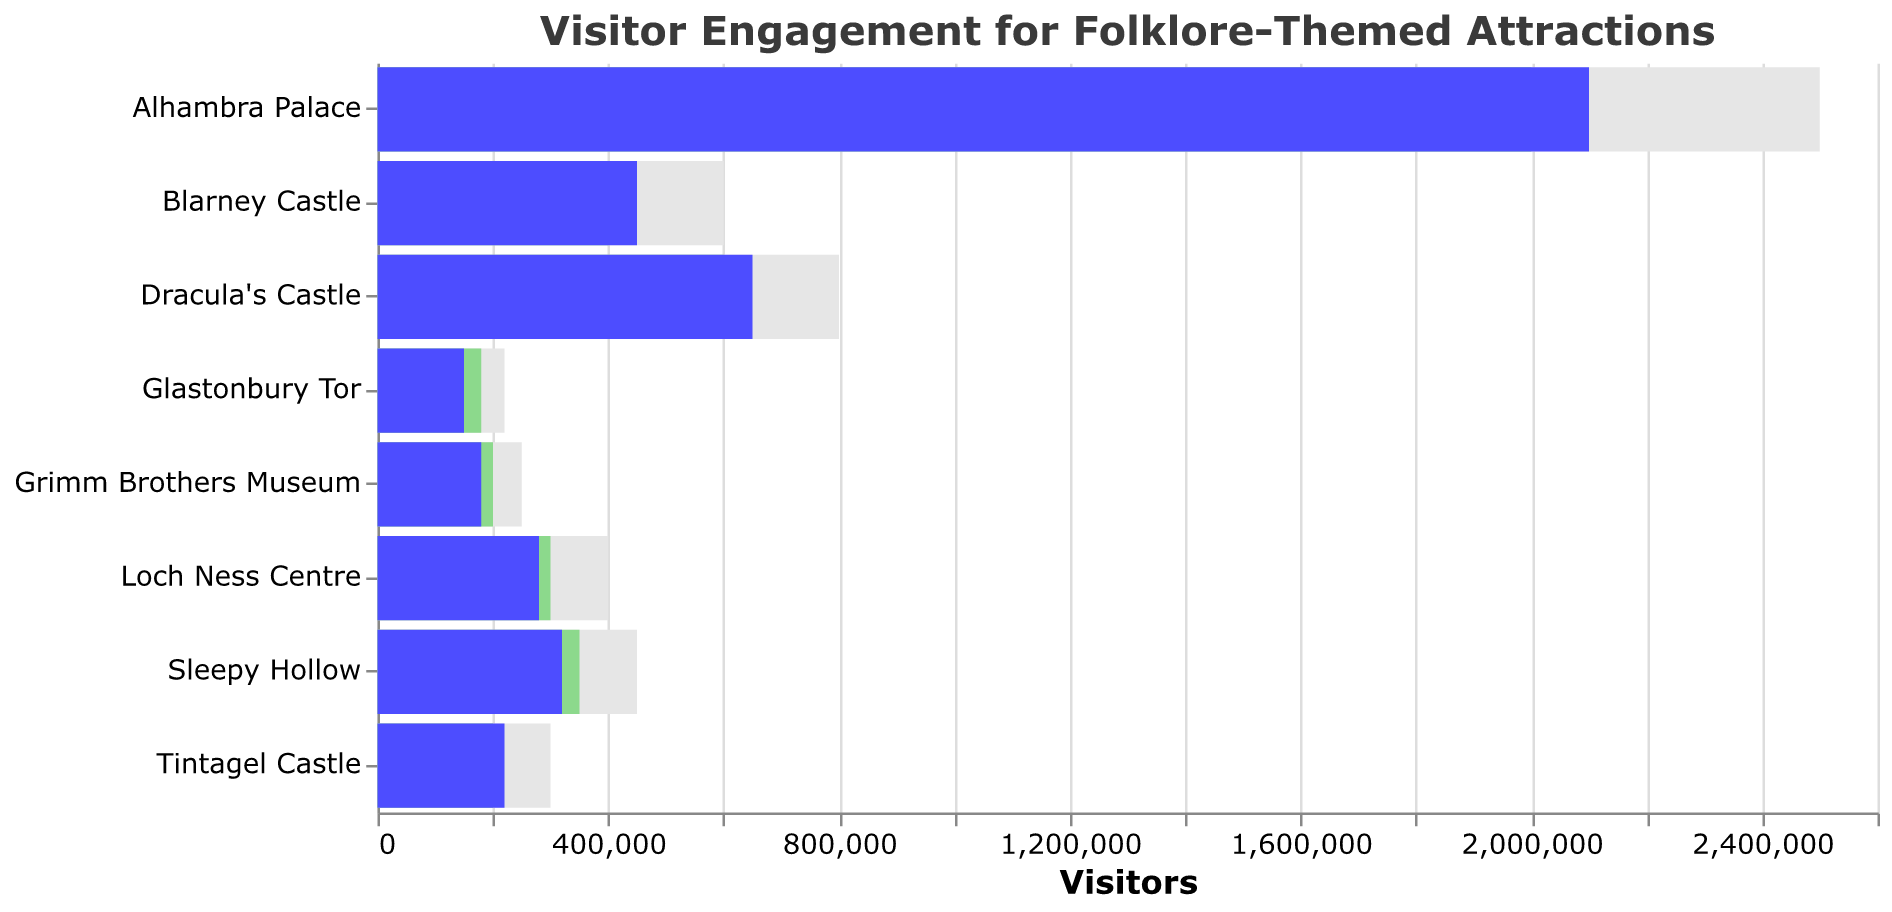What's the title of the chart? The title of the chart is located at the top and reads "Visitor Engagement for Folklore-Themed Attractions".
Answer: Visitor Engagement for Folklore-Themed Attractions How many attractions are displayed in the chart? Count the number of distinct bars for the attractions. There are 8 attractions displayed.
Answer: 8 Which attraction had the highest number of actual visitors? The actual visitors are represented by the blue bars, the longest bar corresponds to Alhambra Palace.
Answer: Alhambra Palace Did Glastonbury Tor meet its target visitor goal? Compare the length of the green (target visitors) bar to the blue (actual visitors) bar for Glastonbury Tor. The actual visitors (150,000) are less than the target (180,000).
Answer: No Which attractions exceeded their target visitor goals? Compare the blue bars (actual visitors) with the green bars (target visitors). Blarney Castle, Dracula's Castle, Tintagel Castle, and Alhambra Palace exceeded their target visitor goals.
Answer: Blarney Castle, Dracula's Castle, Tintagel Castle, Alhambra Palace What is the difference between actual visitors and target visitors for Loch Ness Centre? Subtract the number of target visitors (300,000) from actual visitors (280,000) for Loch Ness Centre.
Answer: -20,000 What percentage of the maximum capacity did Dracula's Castle reach? Divide the actual visitors (650,000) by the maximum capacity (800,000), then multiply by 100 to get the percentage. (650,000 / 800,000) * 100 = 81.25%.
Answer: 81.25% Did any attraction have actual visitors below 50% of its maximum capacity? Compare the actual visitors and check if any are less than half of their maximum capacity. Glastonbury Tor had 150,000 visitors with a maximum capacity of 220,000 (about 68%). All other attractions had more than 50% actual visitors relative to their maximum capacities.
Answer: No Which attraction had the closest actual visitors figure to its target? Determine the absolute difference between actual and target visitors for each attraction and find the smallest difference. Tintagel Castle had actual visitors (220,000) close to target visitors (200,000), difference is 20,000.
Answer: Tintagel Castle 